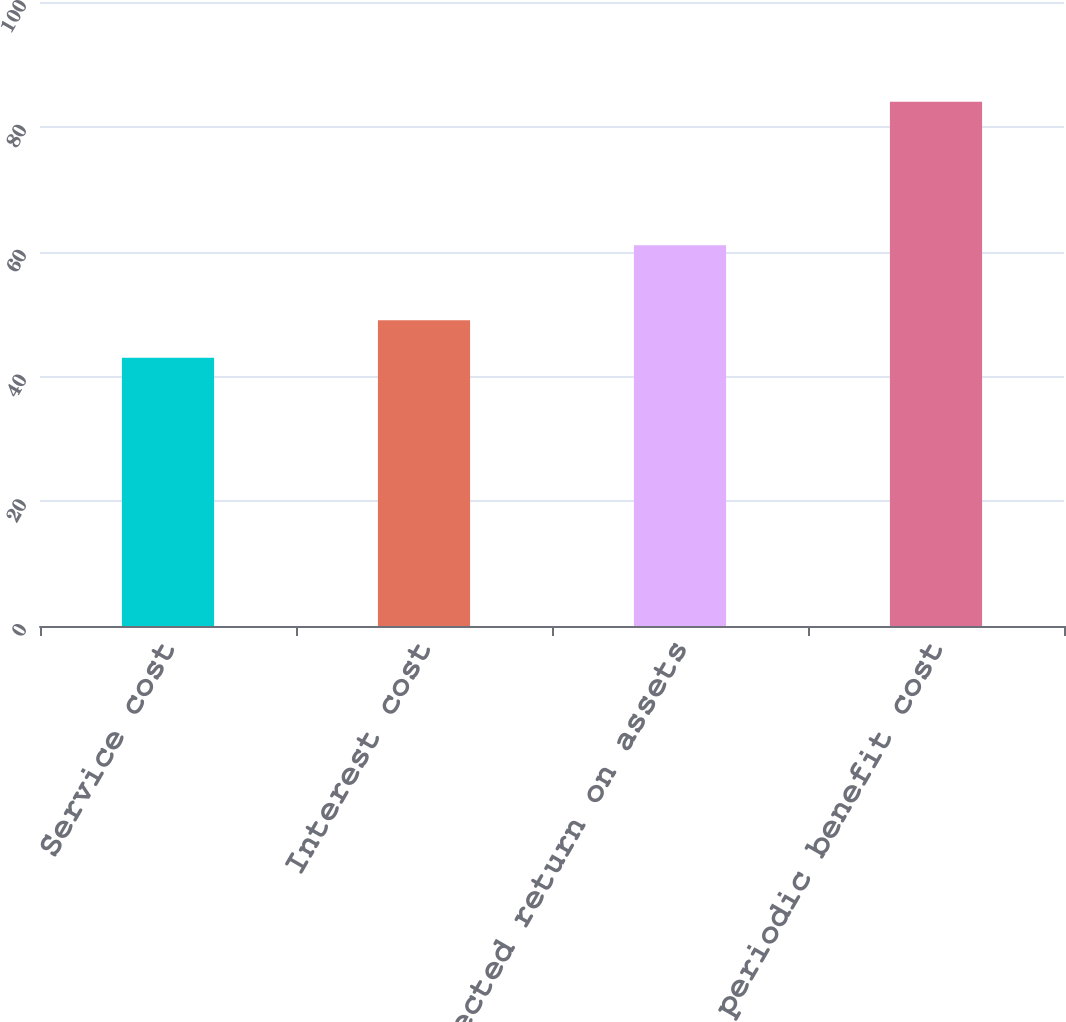Convert chart to OTSL. <chart><loc_0><loc_0><loc_500><loc_500><bar_chart><fcel>Service cost<fcel>Interest cost<fcel>Expected return on assets<fcel>Net periodic benefit cost<nl><fcel>43<fcel>49<fcel>61<fcel>84<nl></chart> 